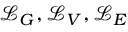<formula> <loc_0><loc_0><loc_500><loc_500>\mathcal { L } _ { G } , \mathcal { L } _ { V } , \mathcal { L } _ { E }</formula> 